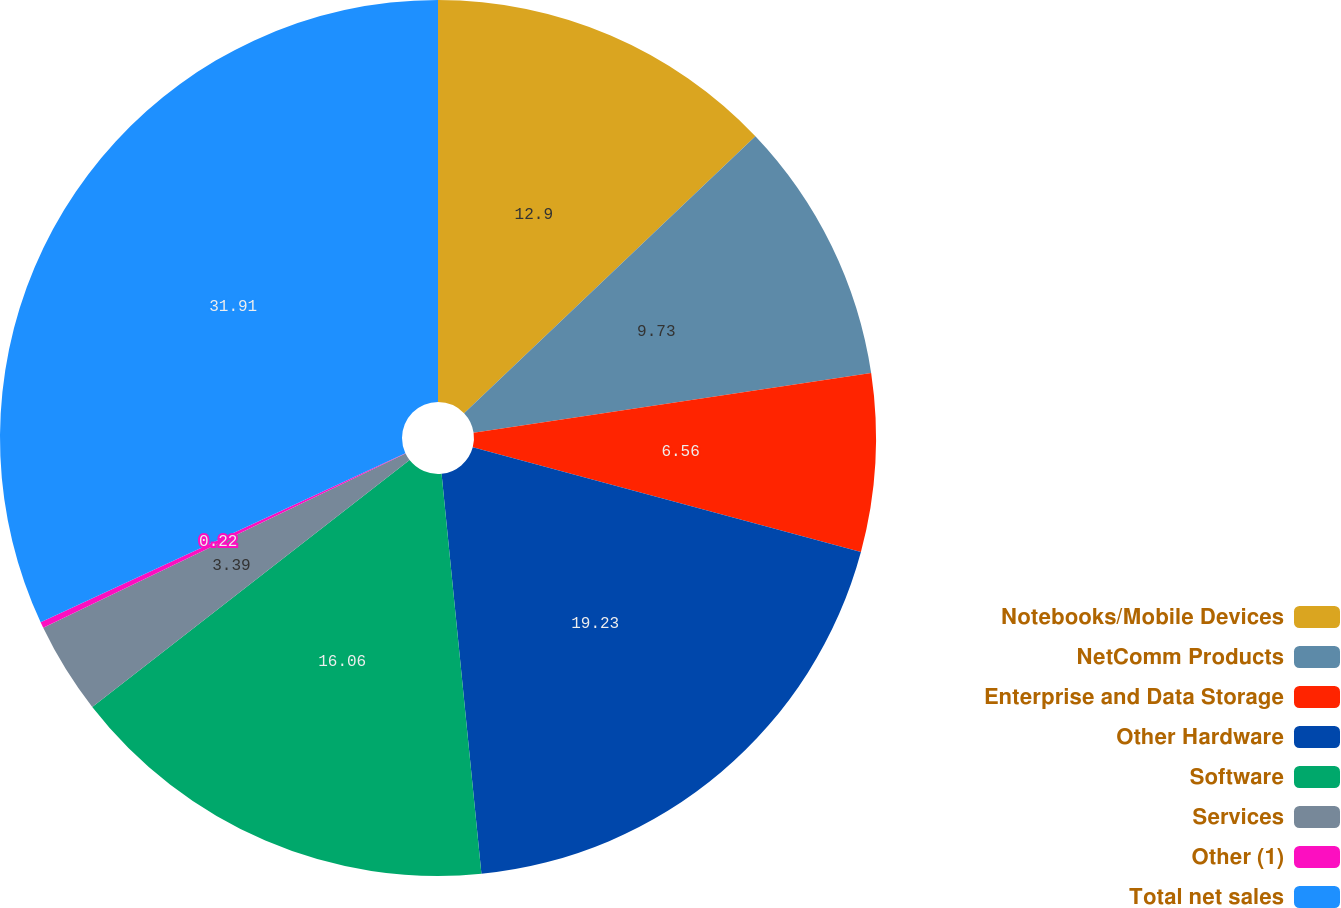Convert chart. <chart><loc_0><loc_0><loc_500><loc_500><pie_chart><fcel>Notebooks/Mobile Devices<fcel>NetComm Products<fcel>Enterprise and Data Storage<fcel>Other Hardware<fcel>Software<fcel>Services<fcel>Other (1)<fcel>Total net sales<nl><fcel>12.9%<fcel>9.73%<fcel>6.56%<fcel>19.23%<fcel>16.06%<fcel>3.39%<fcel>0.22%<fcel>31.91%<nl></chart> 